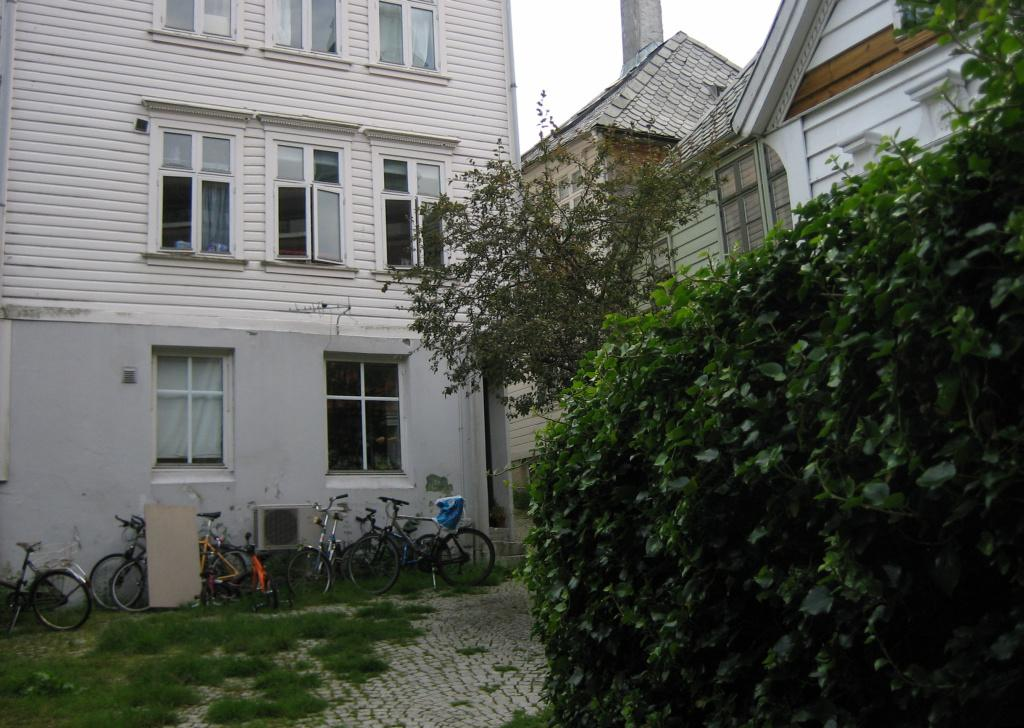What is located in the foreground of the image? There is a plant in the foreground of the image. What can be seen on the left side of the image? There are bicycles on the left side of the image. What type of structure is near the bicycles? There is a house near the bicycles. What is visible in the background of the image? The sky is visible in the background of the image. What type of calendar is hanging on the wall inside the house in the image? There is no calendar visible in the image, as it only shows a plant in the foreground, bicycles and a house on the left side, and the sky in the background. 